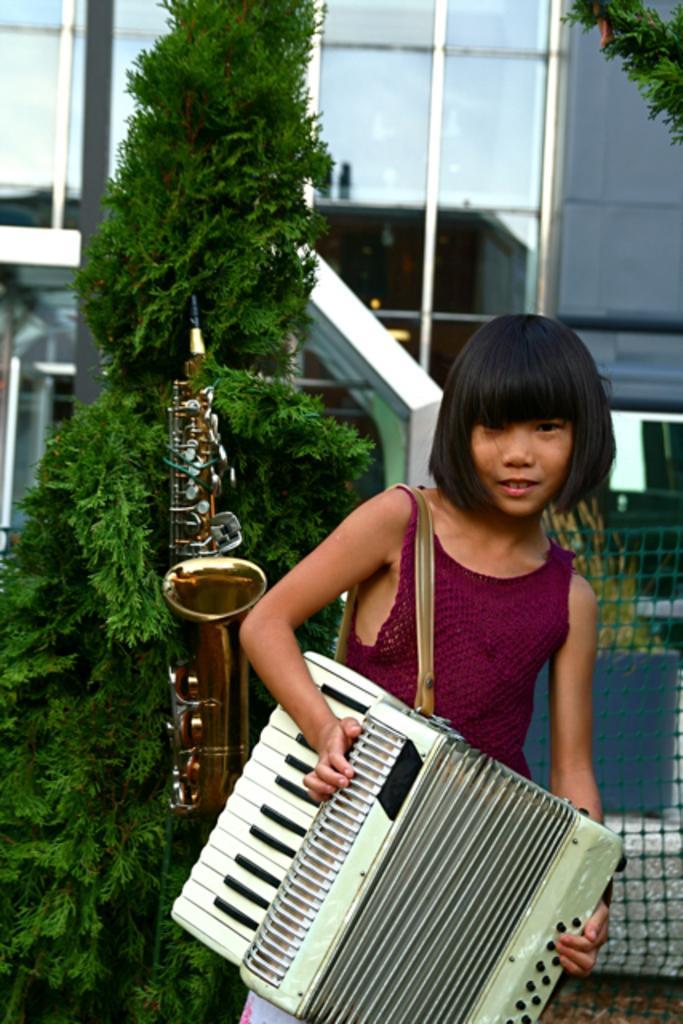How would you summarize this image in a sentence or two? In this picture I can see there is a girl standing and smiling, she is holding an accordion. There is a saxophone behind her and there are plants, a building and it has glasses. 